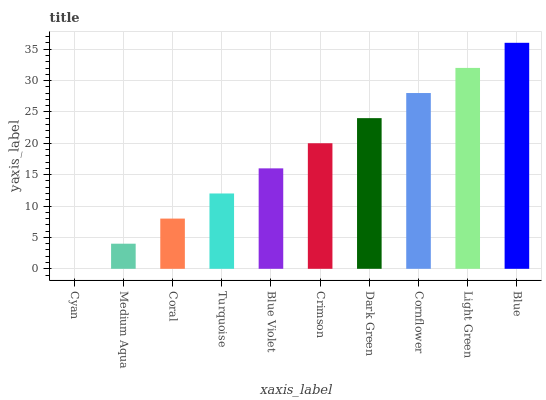Is Cyan the minimum?
Answer yes or no. Yes. Is Blue the maximum?
Answer yes or no. Yes. Is Medium Aqua the minimum?
Answer yes or no. No. Is Medium Aqua the maximum?
Answer yes or no. No. Is Medium Aqua greater than Cyan?
Answer yes or no. Yes. Is Cyan less than Medium Aqua?
Answer yes or no. Yes. Is Cyan greater than Medium Aqua?
Answer yes or no. No. Is Medium Aqua less than Cyan?
Answer yes or no. No. Is Crimson the high median?
Answer yes or no. Yes. Is Blue Violet the low median?
Answer yes or no. Yes. Is Cornflower the high median?
Answer yes or no. No. Is Dark Green the low median?
Answer yes or no. No. 